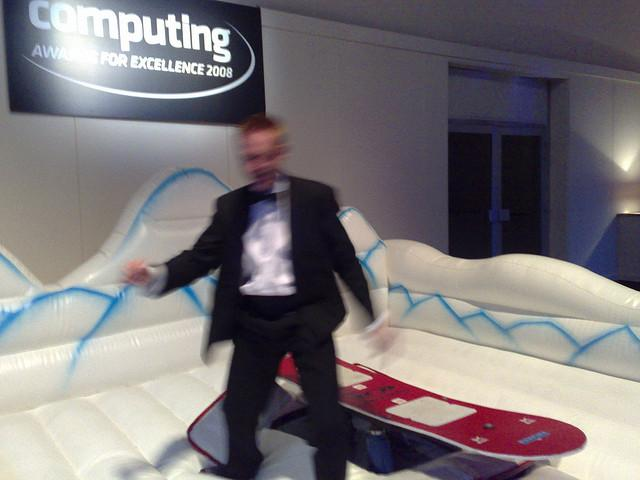The inflatable display is meant to simulate which winter sport? snowboarding 